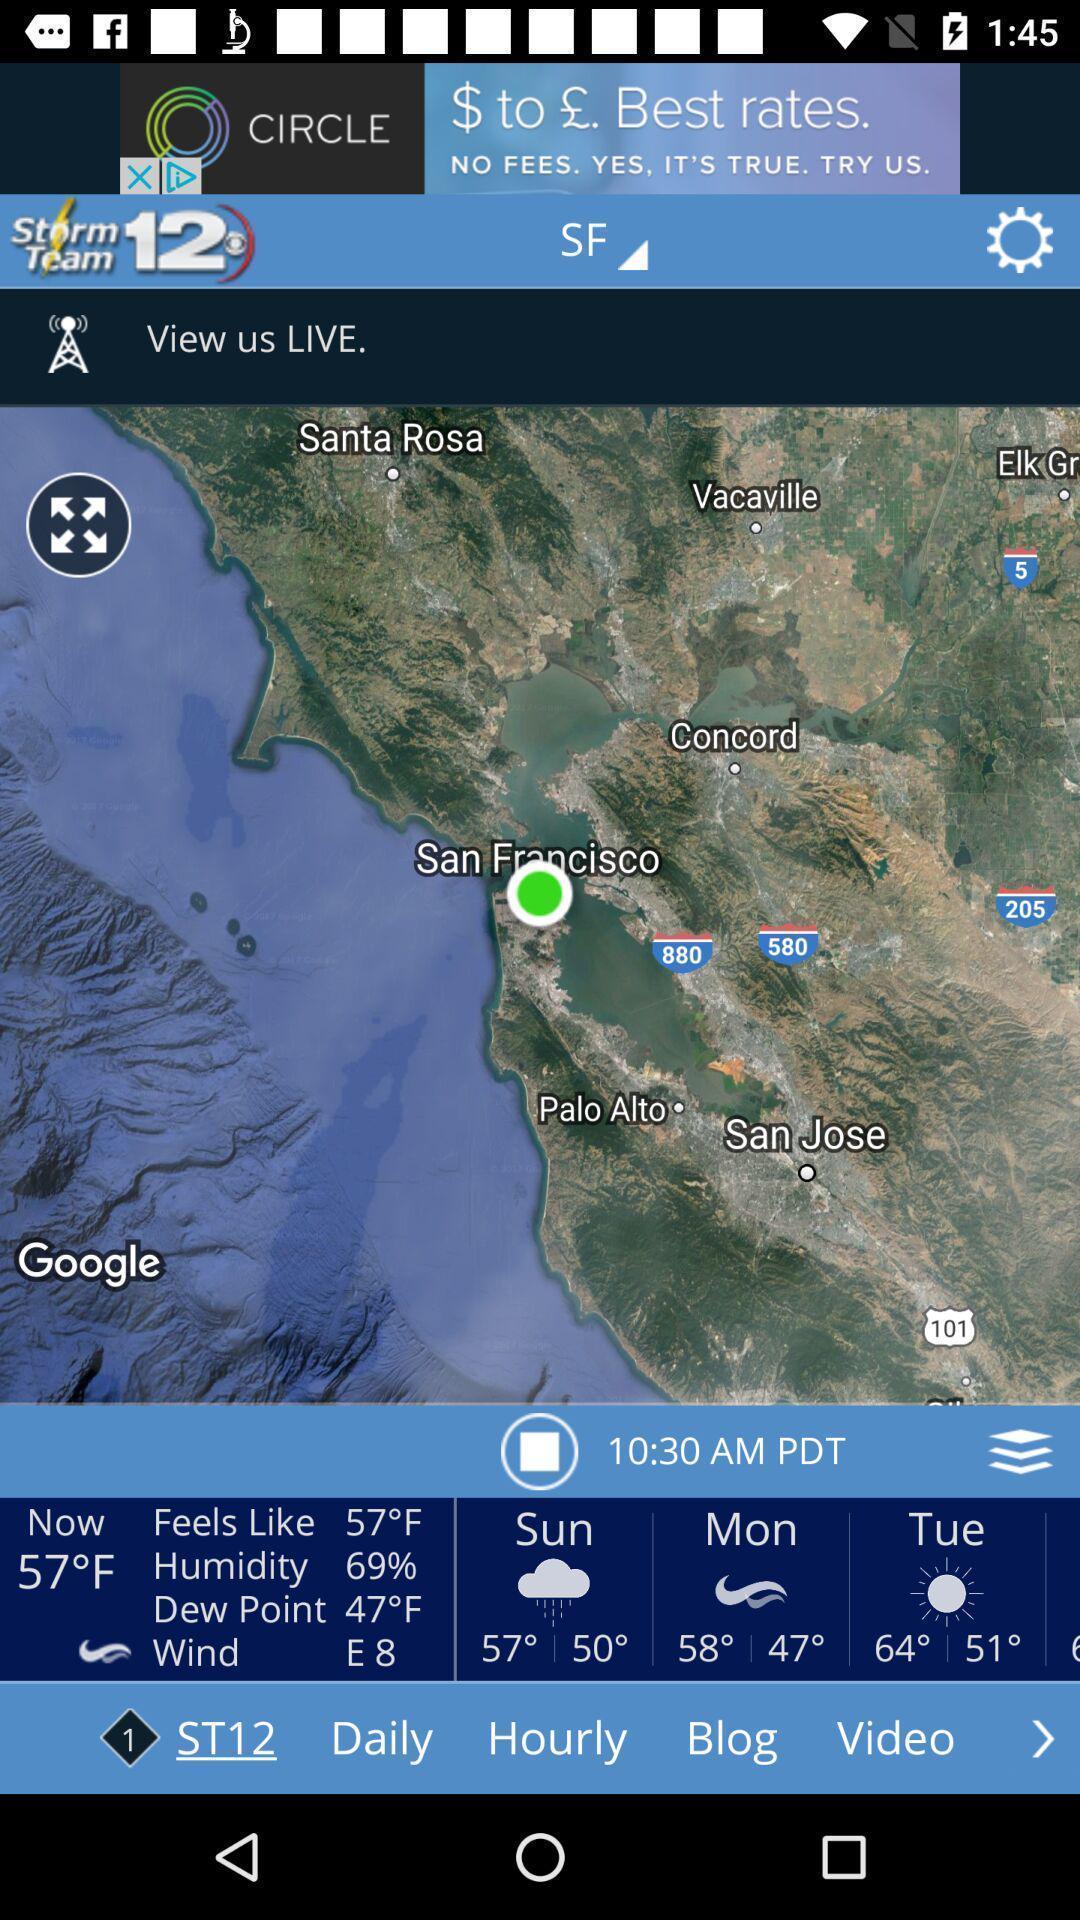Provide a textual representation of this image. Page showing variety of places. 